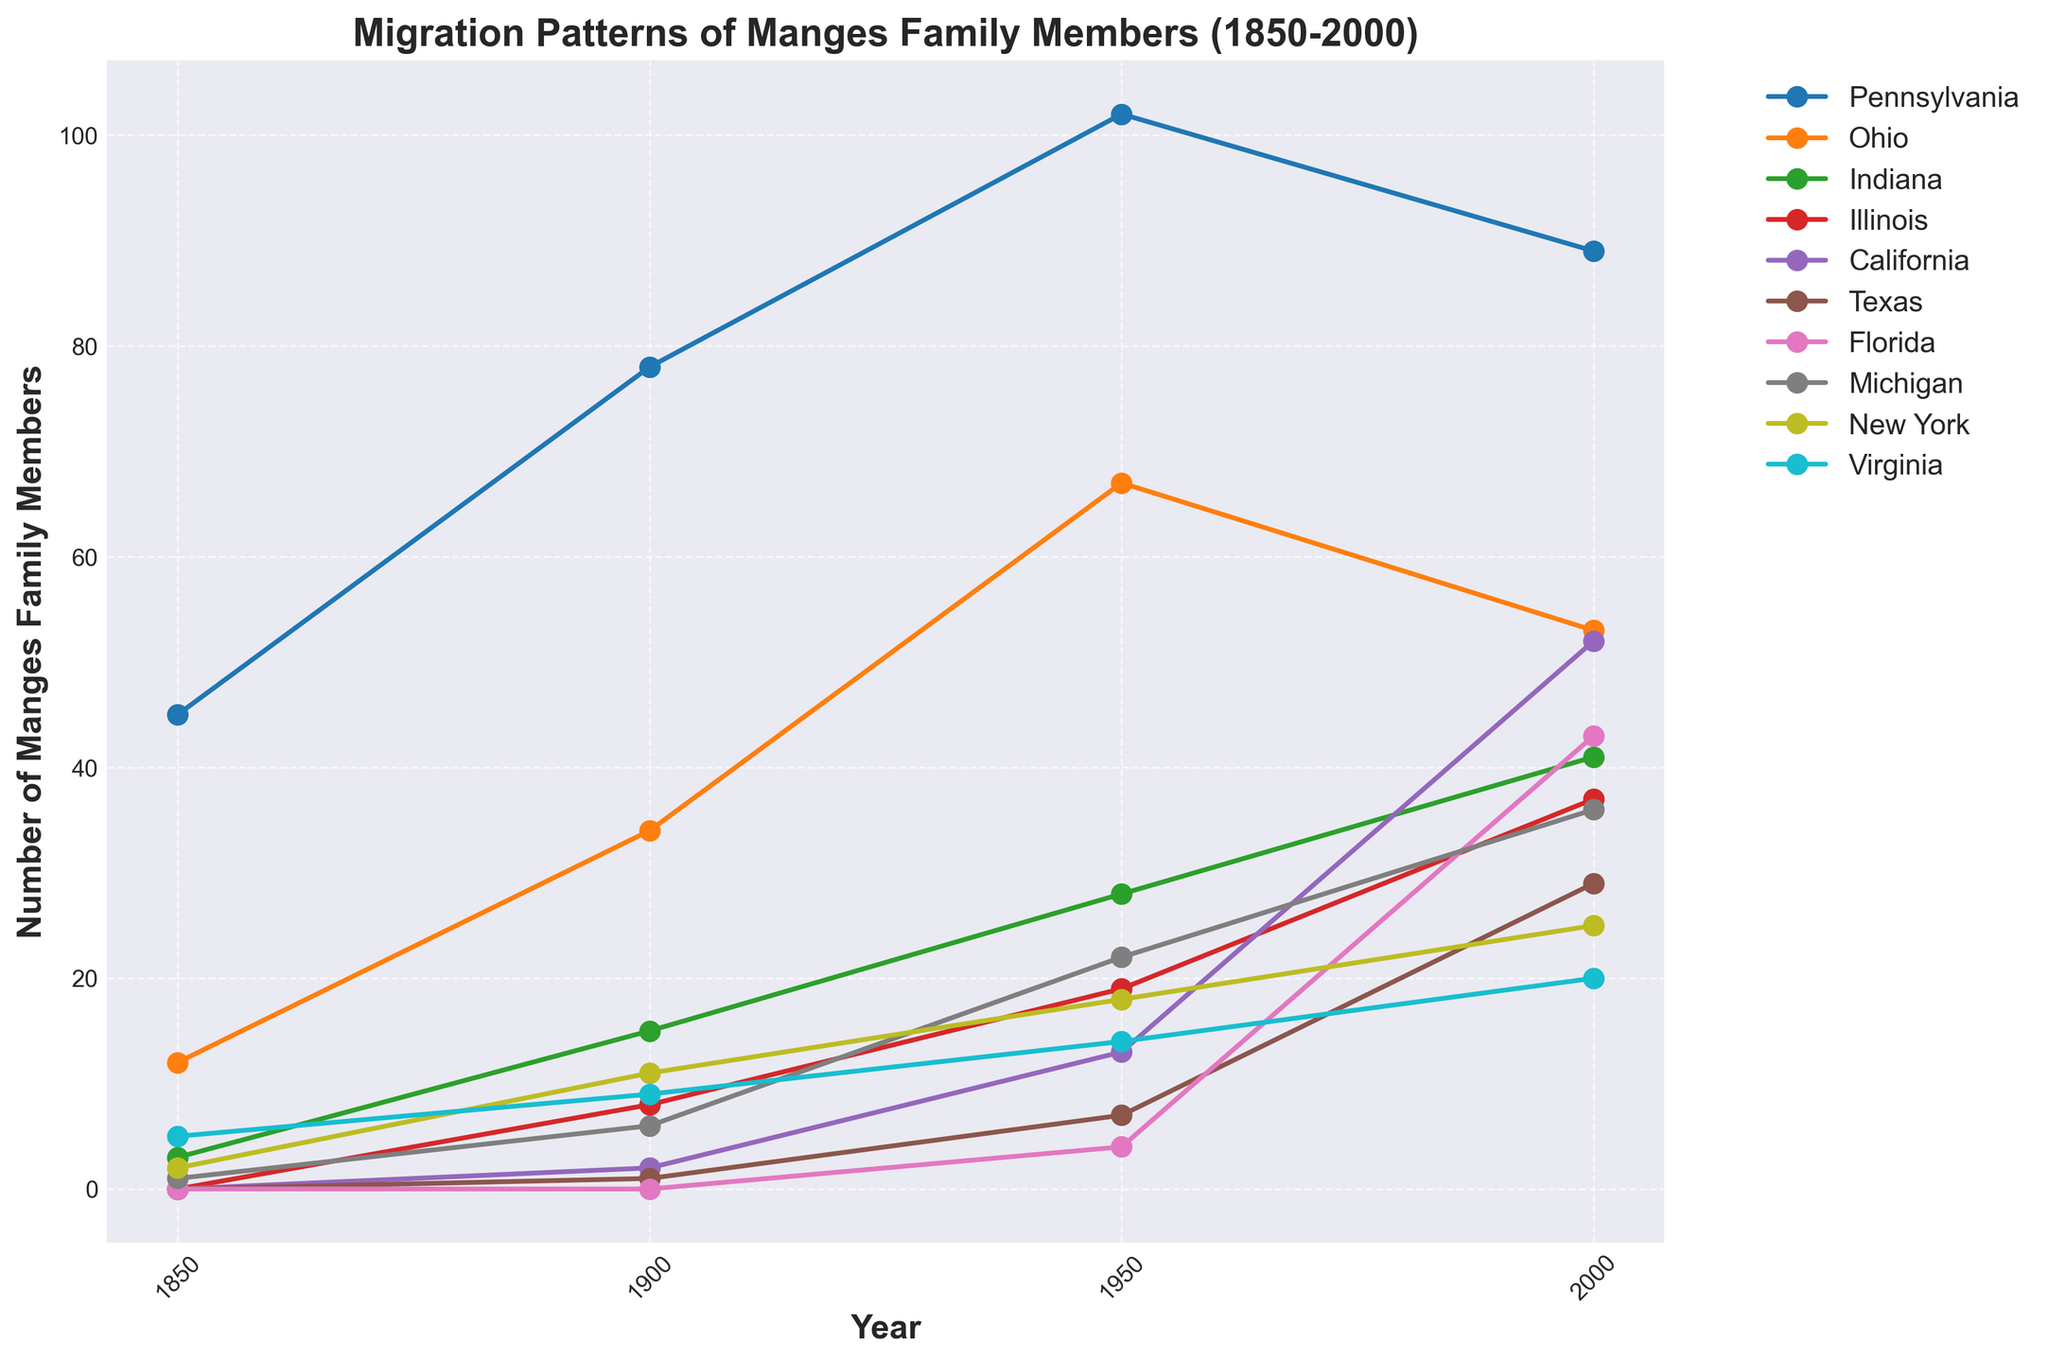Which state had the highest number of Manges family members in 2000? By looking at the end point of each line graph in 2000, we can see that Pennsylvania had the highest number at 89.
Answer: Pennsylvania Which states had no Manges family members in 1850? Observing the initial point of each line graph in 1850, Illinois, California, Texas, and Florida show a value of zero.
Answer: Illinois, California, Texas, Florida What is the total number of Manges family members across all states in 1950? Adding up the values at 1950 for every state: 102 (Pennsylvania) + 67 (Ohio) + 28 (Indiana) + 19 (Illinois) + 13 (California) + 7 (Texas) + 4 (Florida) + 22 (Michigan) + 18 (New York) + 14 (Virginia) = 294.
Answer: 294 Which state saw the largest increase in Manges family members between 1950 and 2000? Calculate the difference between 2000 and 1950 for each state: Pennsylvania (-13), Ohio (-14), Indiana (+13), Illinois (+18), California (+39), Texas (+22), Florida (+39), Michigan (+14), New York (+7), Virginia (+6). Both California and Florida saw the largest increase of +39.
Answer: California, Florida How do the 2000 figures for Indiana and Illinois compare? Indiana had 41 and Illinois had 37 in 2000. Therefore, Indiana had more than Illinois by 4.
Answer: Indiana has 4 more Which year did Ohio surpass Pennsylvania in terms of family members? By referring to the point where the Ohio line crosses above the Pennsylvania line, it is around 1950.
Answer: 1950 What is the average number of Manges family members in Michigan over the recorded years? Sum the values in Michigan (1 + 6 + 22 + 36) and divide by the number of years (4). The average is (1+6+22+36)/4 = 65/4 = 16.25.
Answer: 16.25 Which state experienced the smallest change in the number of Manges family members from 1850 to 2000? Find the absolute difference between the values in 1850 and 2000 for each state. Pennsylvania (89-45=44), Ohio (53-12=41), Indiana (41-3=38), Illinois (37-0=37), California (52-0=52), Texas (29-0=29), Florida (43-0=43), Michigan (36-1=35), New York (25-2=23), Virginia (20-5=15). Virginia has the smallest change with 15.
Answer: Virginia How did the number of Manges family members in California change from 1850 to 1950? Observing the values for California from 1850 (0) to 1950 (13), the increase is 13.
Answer: Increased by 13 What is the trend for Texas migration from 1850 to 2000? Observing the line for Texas, which starts at 0 in 1850 and gradually increases, reaching 29 in 2000, we see a steady upward trend.
Answer: Steady upward trend 